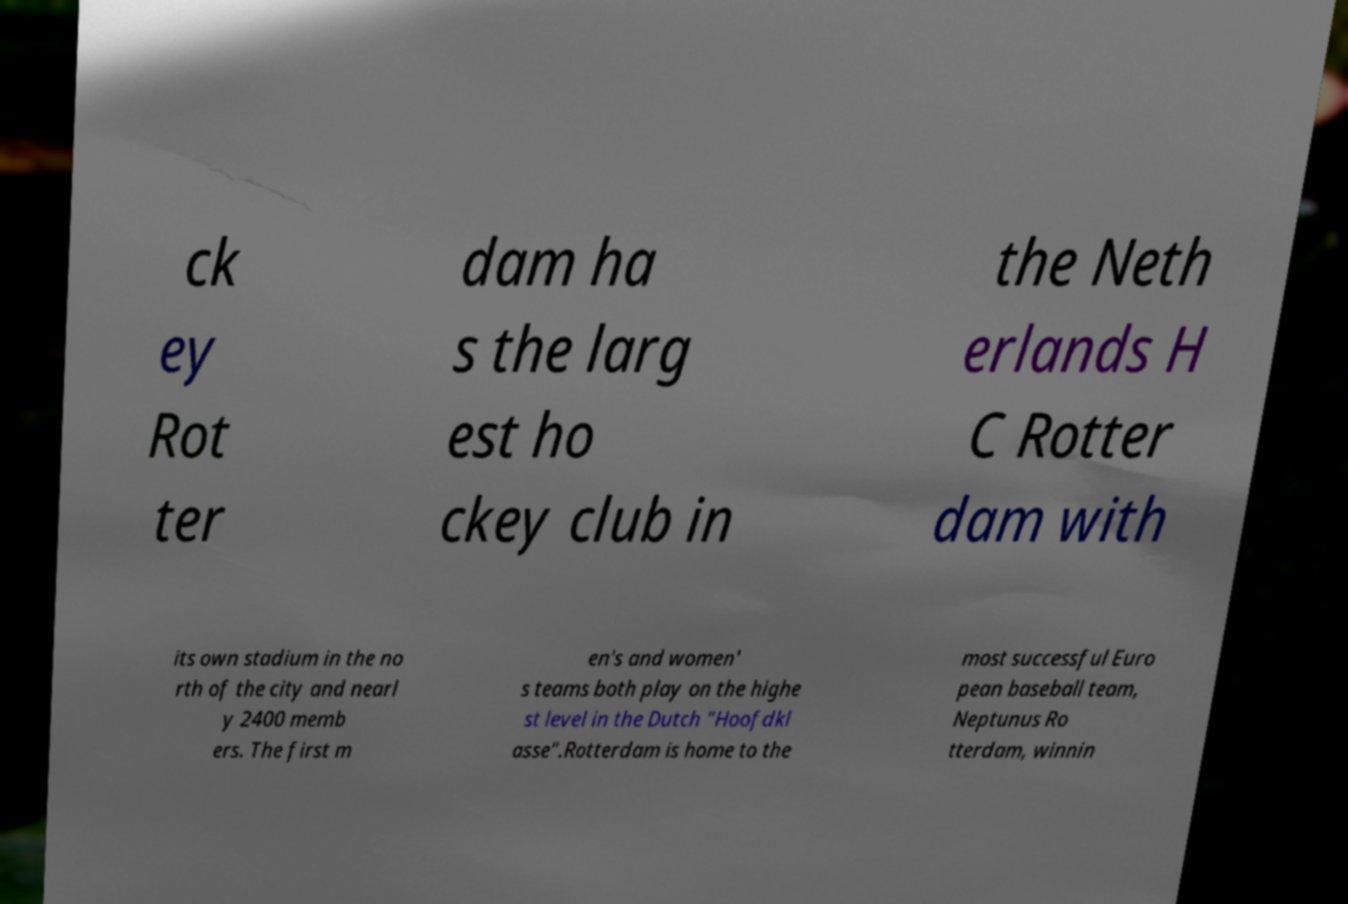Please identify and transcribe the text found in this image. ck ey Rot ter dam ha s the larg est ho ckey club in the Neth erlands H C Rotter dam with its own stadium in the no rth of the city and nearl y 2400 memb ers. The first m en's and women' s teams both play on the highe st level in the Dutch "Hoofdkl asse".Rotterdam is home to the most successful Euro pean baseball team, Neptunus Ro tterdam, winnin 